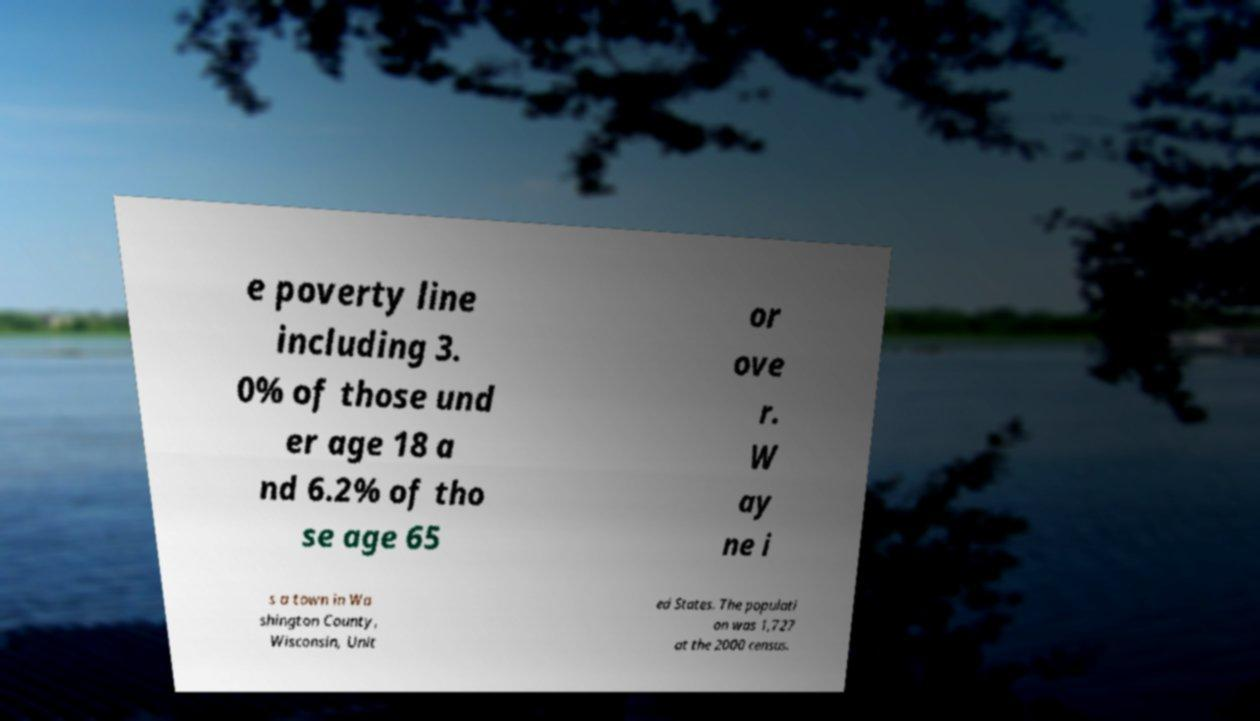There's text embedded in this image that I need extracted. Can you transcribe it verbatim? e poverty line including 3. 0% of those und er age 18 a nd 6.2% of tho se age 65 or ove r. W ay ne i s a town in Wa shington County, Wisconsin, Unit ed States. The populati on was 1,727 at the 2000 census. 